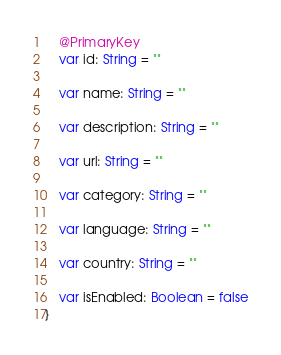Convert code to text. <code><loc_0><loc_0><loc_500><loc_500><_Kotlin_>
    @PrimaryKey
    var id: String = ""

    var name: String = ""

    var description: String = ""

    var url: String = ""

    var category: String = ""

    var language: String = ""

    var country: String = ""

    var isEnabled: Boolean = false
}
</code> 